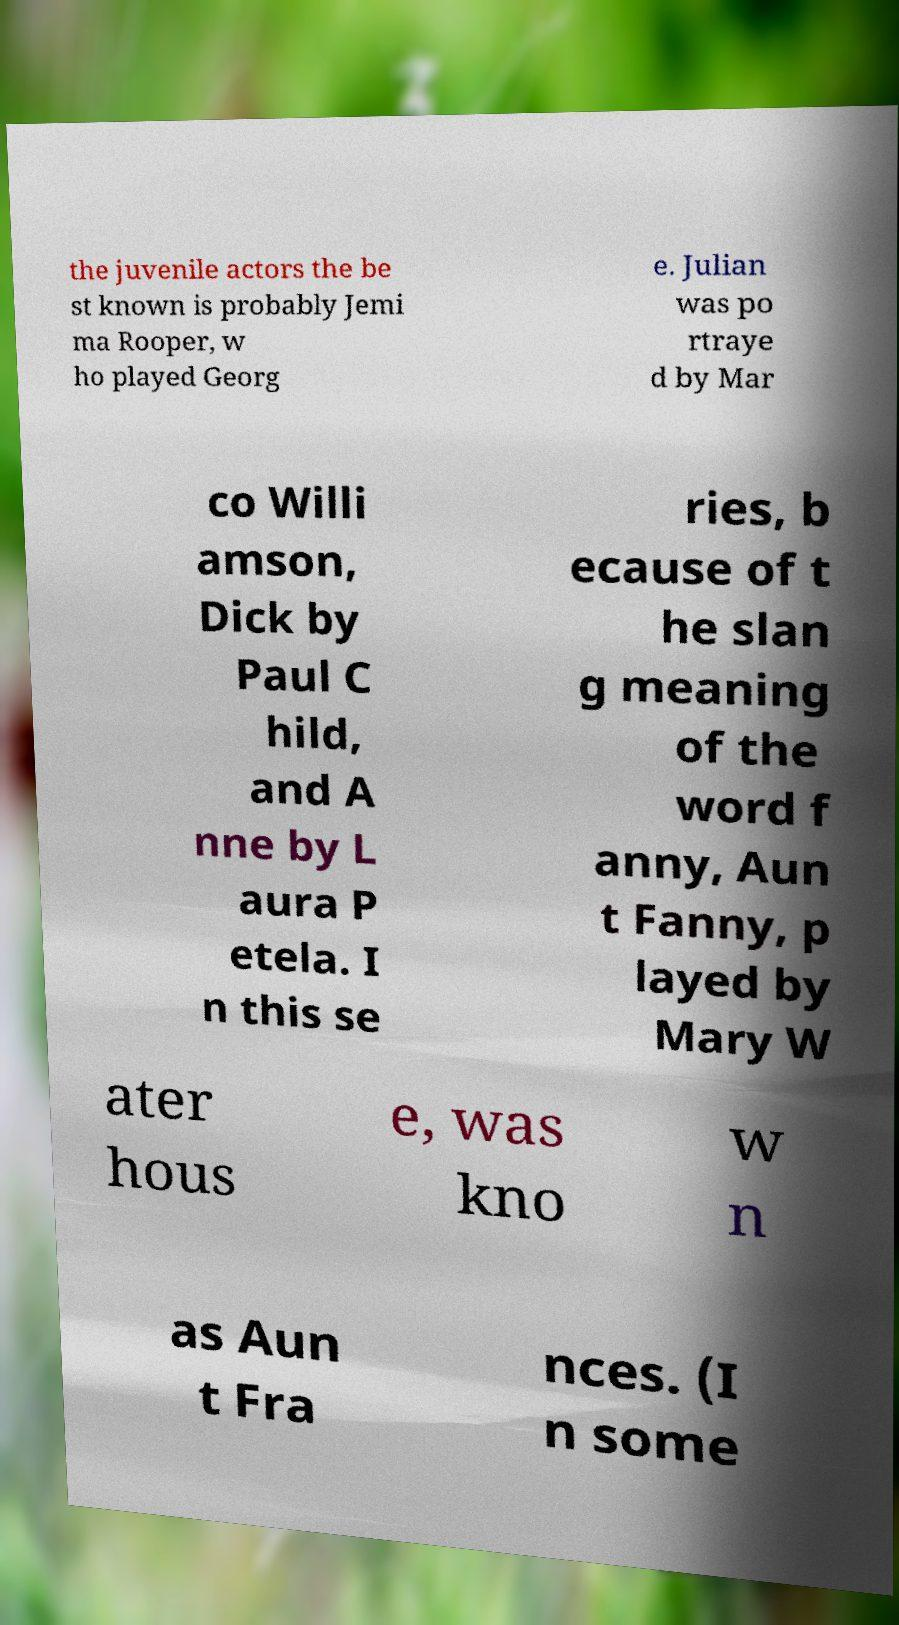For documentation purposes, I need the text within this image transcribed. Could you provide that? the juvenile actors the be st known is probably Jemi ma Rooper, w ho played Georg e. Julian was po rtraye d by Mar co Willi amson, Dick by Paul C hild, and A nne by L aura P etela. I n this se ries, b ecause of t he slan g meaning of the word f anny, Aun t Fanny, p layed by Mary W ater hous e, was kno w n as Aun t Fra nces. (I n some 